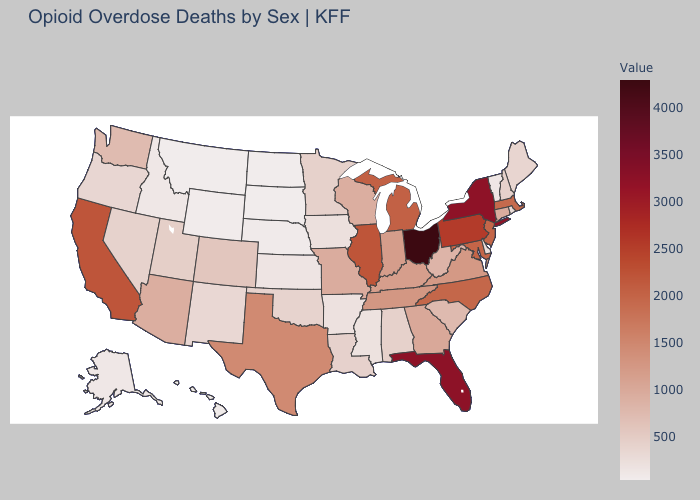Does the map have missing data?
Keep it brief. No. Which states hav the highest value in the Northeast?
Concise answer only. New York. Which states have the highest value in the USA?
Give a very brief answer. Ohio. Does Kentucky have the highest value in the USA?
Keep it brief. No. 